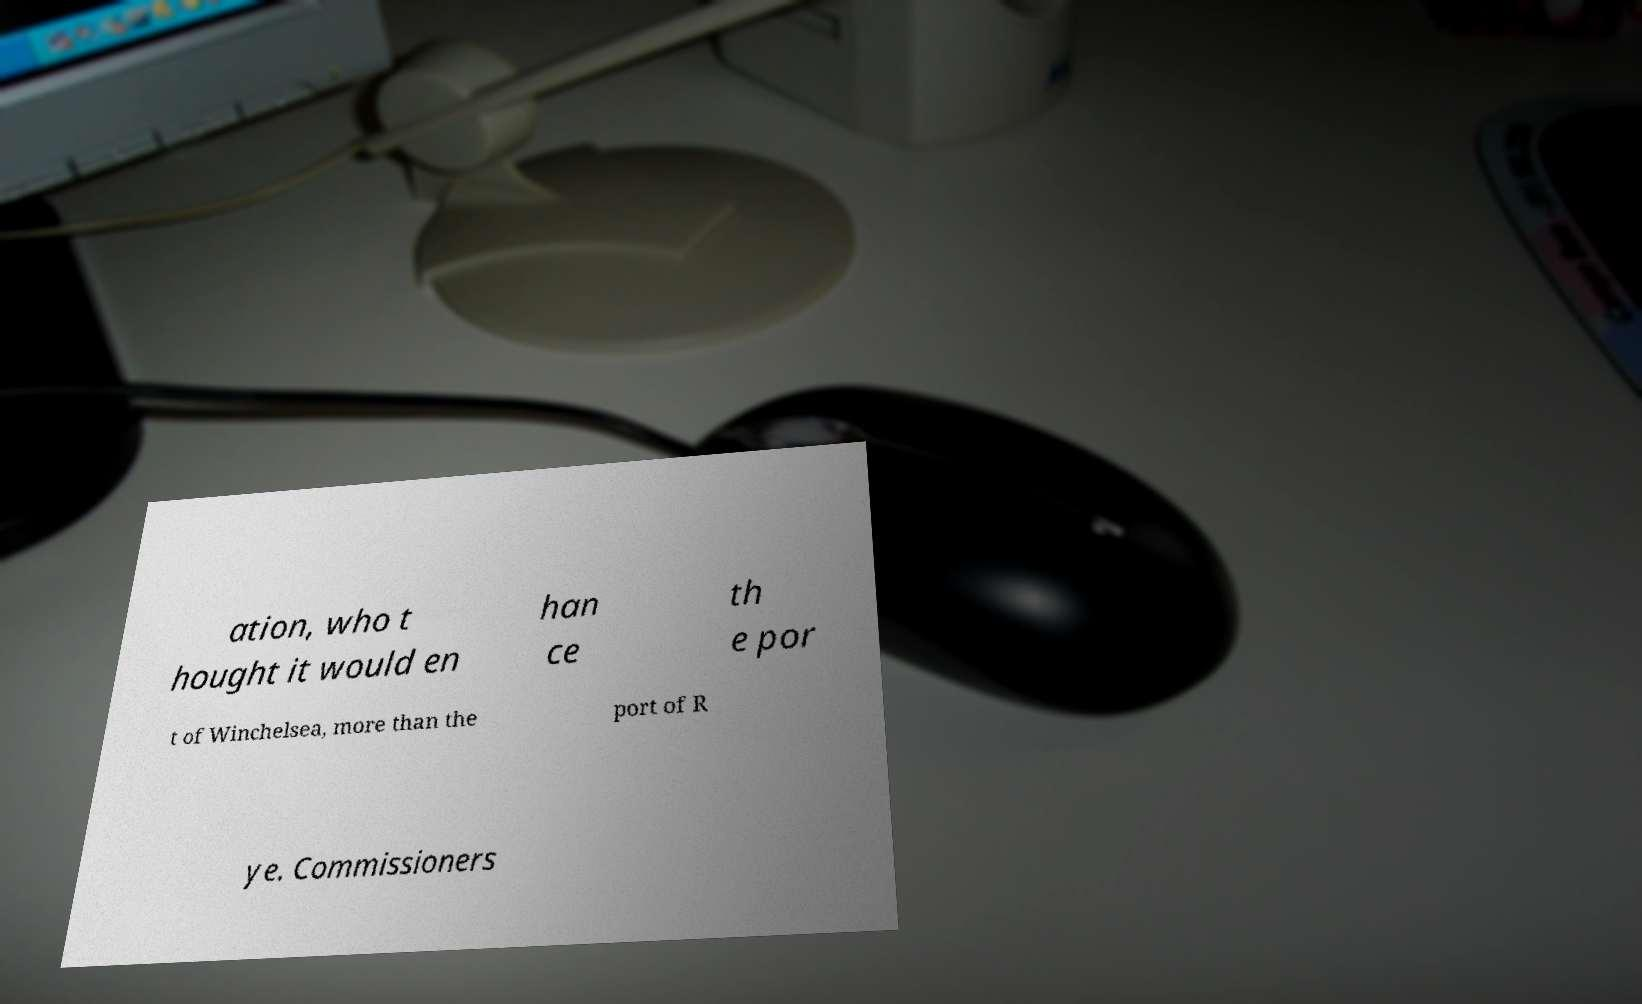I need the written content from this picture converted into text. Can you do that? ation, who t hought it would en han ce th e por t of Winchelsea, more than the port of R ye. Commissioners 